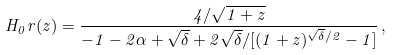<formula> <loc_0><loc_0><loc_500><loc_500>H _ { 0 } r ( z ) = \frac { 4 / \sqrt { 1 + z } } { - 1 - 2 \alpha + \sqrt { \delta } + 2 \sqrt { \delta } / [ ( 1 + z ) ^ { \sqrt { \delta } / 2 } - 1 ] } \, ,</formula> 